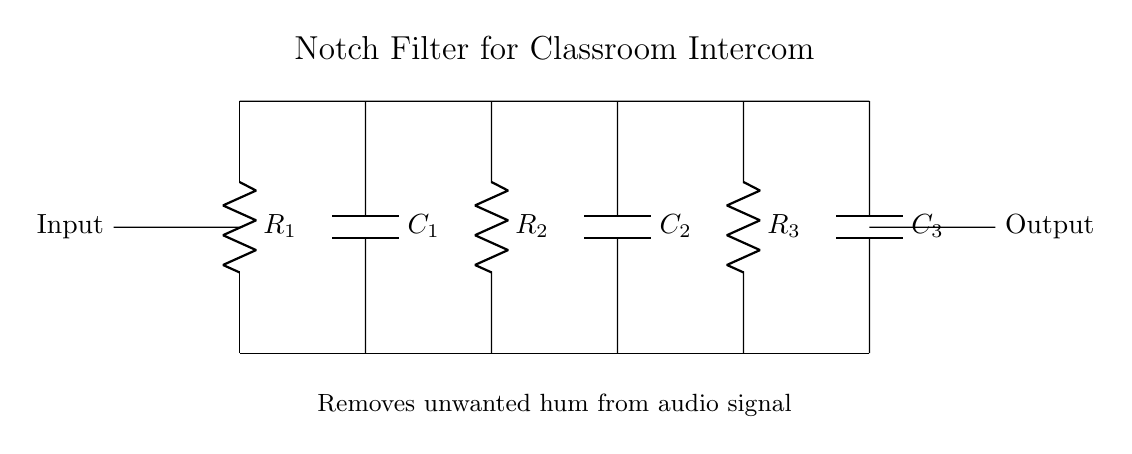What are the components in the circuit? The components in the circuit include resistors and capacitors, which are labeled as R1, R2, R3, C1, C2, and C3 in the diagram.
Answer: Resistors and capacitors What is the purpose of this notch filter? The purpose of the notch filter is to remove unwanted hum from the audio signal in the intercom system, making the sound clearer.
Answer: Remove unwanted hum How many resistors are in the circuit? There are three resistors labeled as R1, R2, and R3.
Answer: Three What is the input to the circuit? The input to the circuit is at the left side, labeled as "Input," where the audio signal enters the filter.
Answer: Audio signal What is the frequency response of a notch filter? A notch filter typically has a frequency response that allows most frequencies to pass while attenuating a narrow range of frequencies, thus removing hum at specific unwanted frequencies.
Answer: Attenuates specific frequencies Why are there both capacitors and resistors in the circuit? The combination of capacitors and resistors creates a circuit that can selectively filter certain frequencies, allowing the notch filter to effectively target and eliminate the hum from the intercom system.
Answer: Create frequency-selective filtering 